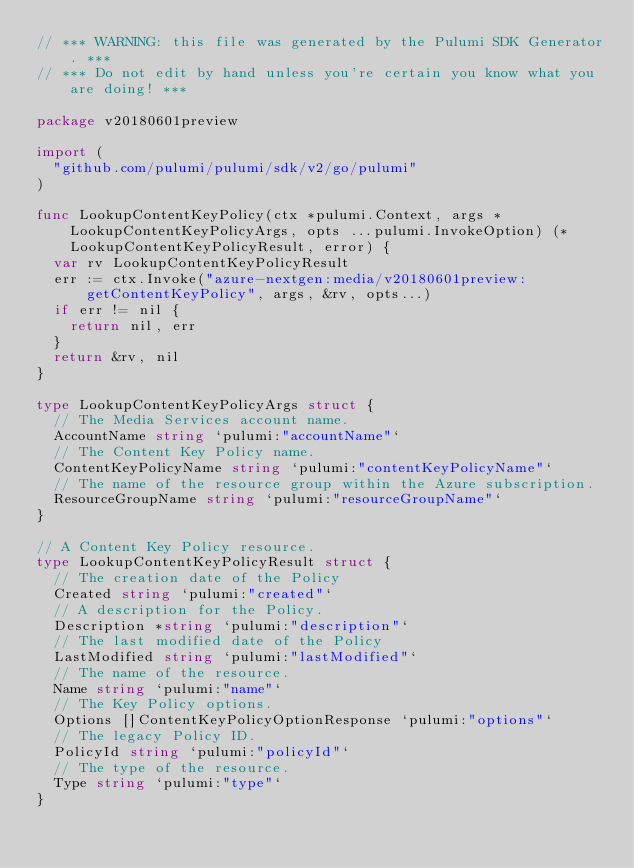Convert code to text. <code><loc_0><loc_0><loc_500><loc_500><_Go_>// *** WARNING: this file was generated by the Pulumi SDK Generator. ***
// *** Do not edit by hand unless you're certain you know what you are doing! ***

package v20180601preview

import (
	"github.com/pulumi/pulumi/sdk/v2/go/pulumi"
)

func LookupContentKeyPolicy(ctx *pulumi.Context, args *LookupContentKeyPolicyArgs, opts ...pulumi.InvokeOption) (*LookupContentKeyPolicyResult, error) {
	var rv LookupContentKeyPolicyResult
	err := ctx.Invoke("azure-nextgen:media/v20180601preview:getContentKeyPolicy", args, &rv, opts...)
	if err != nil {
		return nil, err
	}
	return &rv, nil
}

type LookupContentKeyPolicyArgs struct {
	// The Media Services account name.
	AccountName string `pulumi:"accountName"`
	// The Content Key Policy name.
	ContentKeyPolicyName string `pulumi:"contentKeyPolicyName"`
	// The name of the resource group within the Azure subscription.
	ResourceGroupName string `pulumi:"resourceGroupName"`
}

// A Content Key Policy resource.
type LookupContentKeyPolicyResult struct {
	// The creation date of the Policy
	Created string `pulumi:"created"`
	// A description for the Policy.
	Description *string `pulumi:"description"`
	// The last modified date of the Policy
	LastModified string `pulumi:"lastModified"`
	// The name of the resource.
	Name string `pulumi:"name"`
	// The Key Policy options.
	Options []ContentKeyPolicyOptionResponse `pulumi:"options"`
	// The legacy Policy ID.
	PolicyId string `pulumi:"policyId"`
	// The type of the resource.
	Type string `pulumi:"type"`
}
</code> 